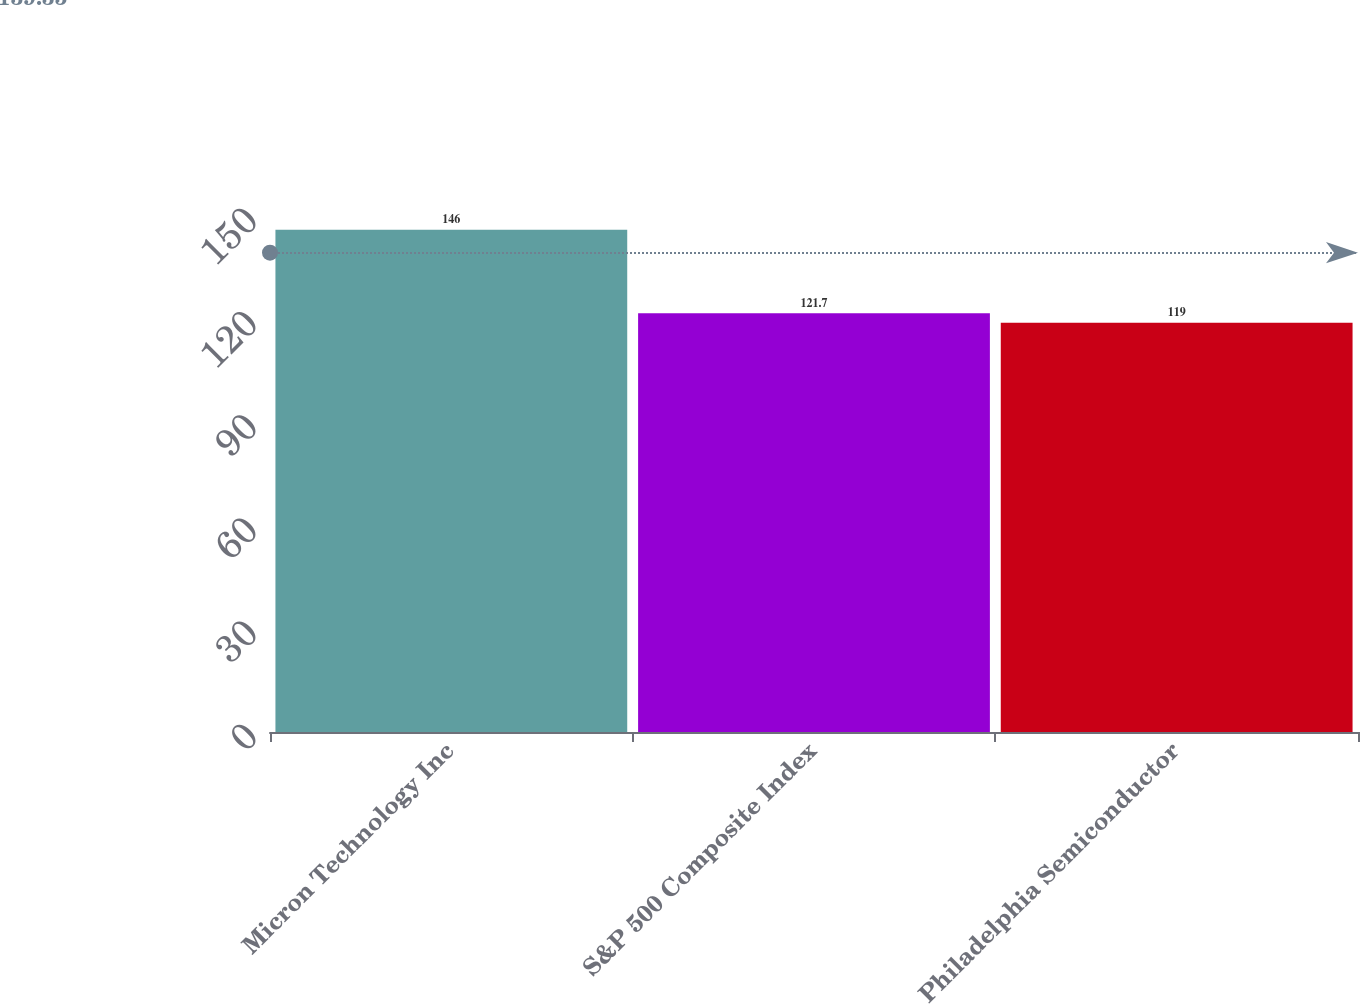Convert chart. <chart><loc_0><loc_0><loc_500><loc_500><bar_chart><fcel>Micron Technology Inc<fcel>S&P 500 Composite Index<fcel>Philadelphia Semiconductor<nl><fcel>146<fcel>121.7<fcel>119<nl></chart> 